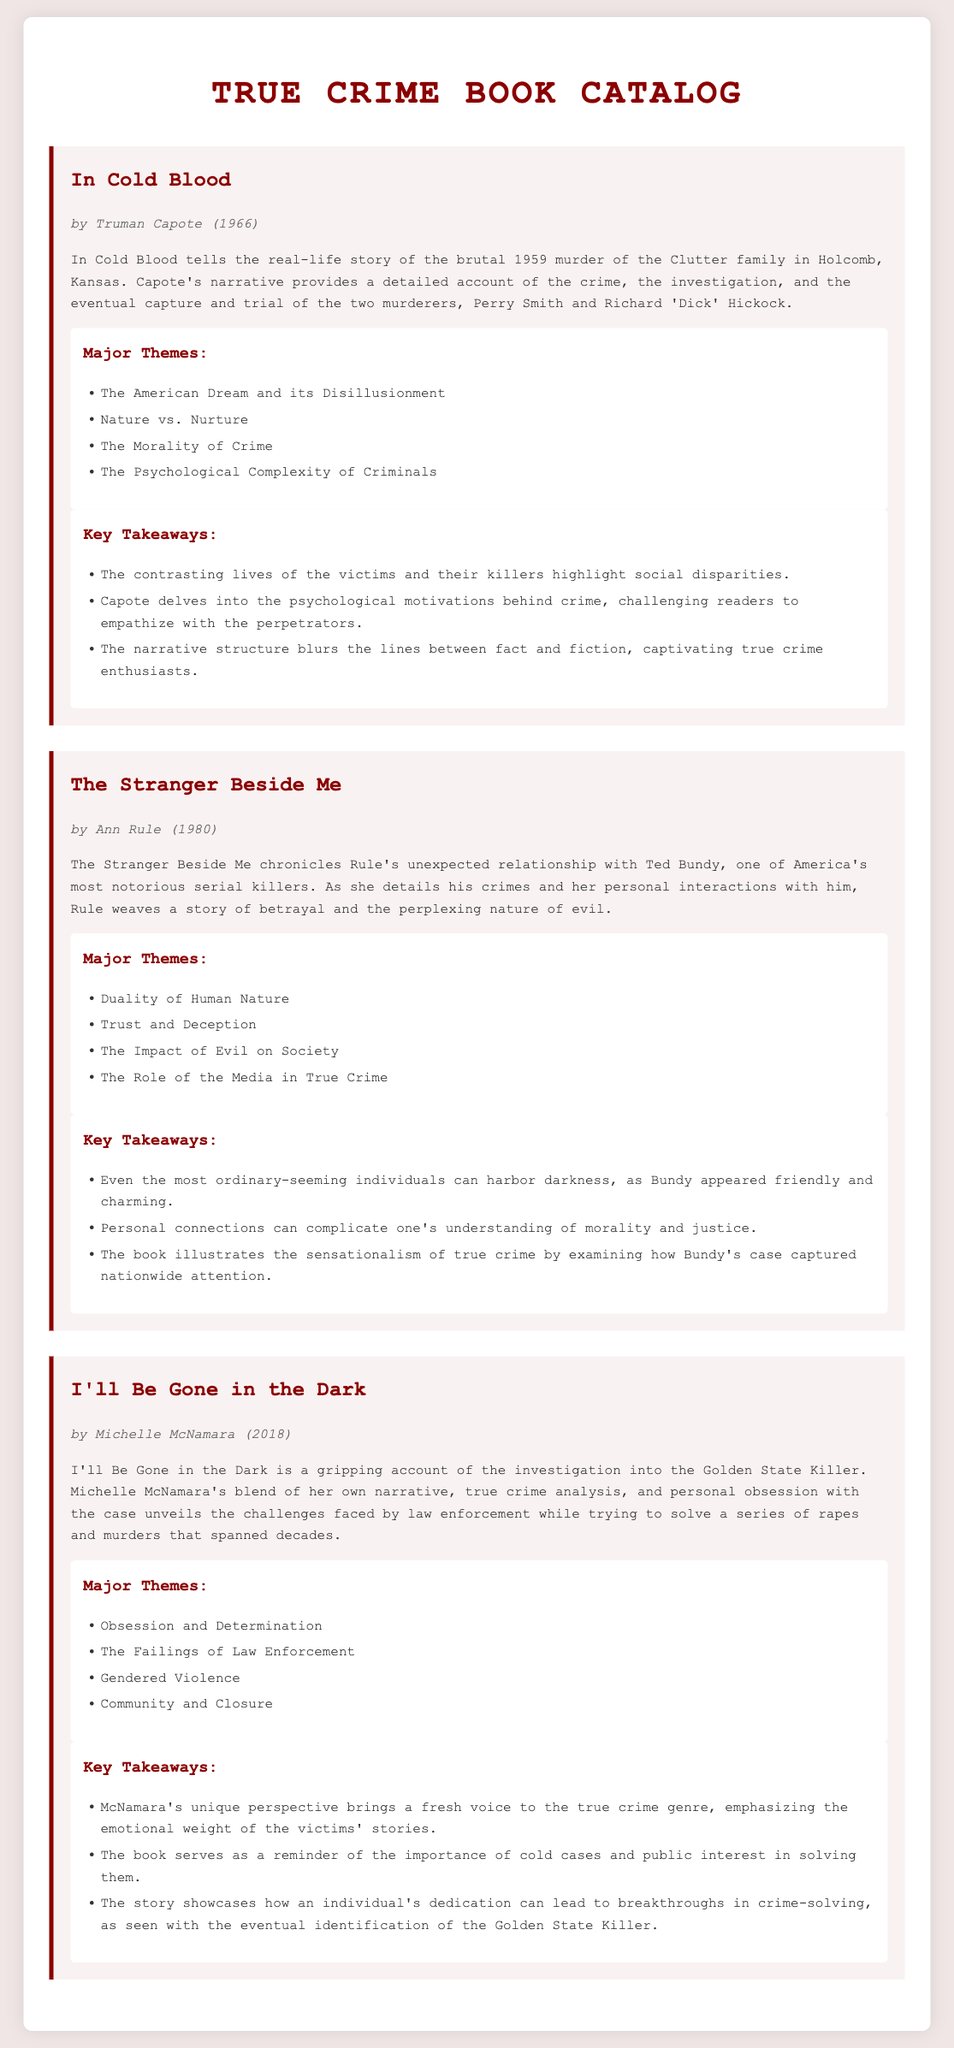What is the title of the first book? The title of the first book listed in the document is “In Cold Blood.”
Answer: In Cold Blood Who is the author of "The Stranger Beside Me"? The author of "The Stranger Beside Me" is Ann Rule.
Answer: Ann Rule What year was "I'll Be Gone in the Dark" published? "I'll Be Gone in the Dark" was published in 2018.
Answer: 2018 Which theme is present in both "In Cold Blood" and "The Stranger Beside Me"? Both books explore the major theme of "The Morality of Crime."
Answer: The Morality of Crime How many major themes are listed for "I'll Be Gone in the Dark"? There are four major themes listed for "I'll Be Gone in the Dark."
Answer: Four What psychological aspect does "In Cold Blood" challenge readers to empathize with? "In Cold Blood" challenges readers to empathize with the psychological motivations behind crime.
Answer: Psychological motivations What is the focus of Michelle McNamara's narrative in "I'll Be Gone in the Dark"? The focus of Michelle McNamara's narrative is the investigation into the Golden State Killer.
Answer: The investigation into the Golden State Killer Which book highlights the concept of trust and deception? "The Stranger Beside Me" highlights the concept of trust and deception.
Answer: The Stranger Beside Me 